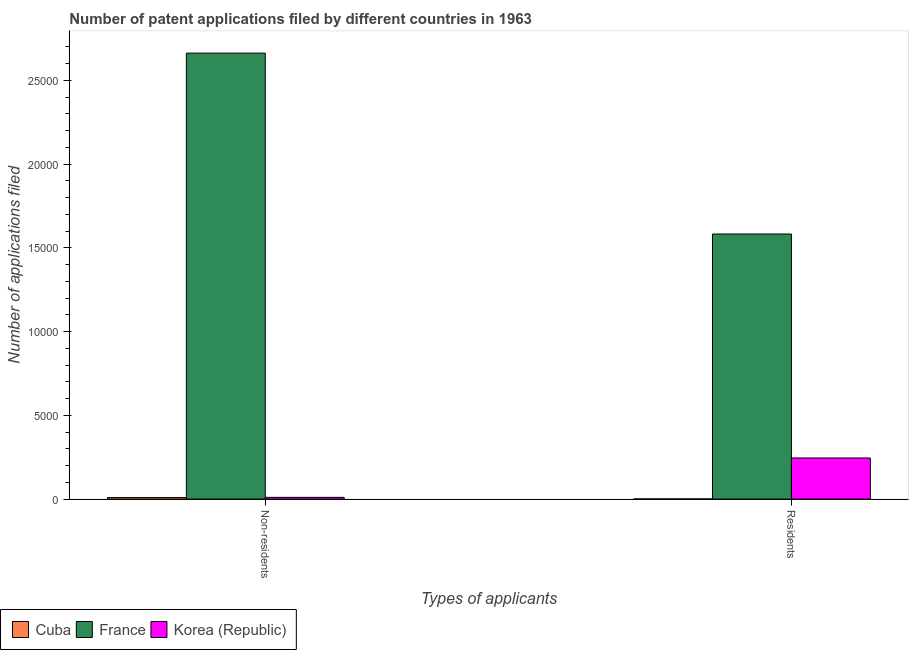Are the number of bars per tick equal to the number of legend labels?
Your answer should be very brief. Yes. How many bars are there on the 1st tick from the right?
Offer a terse response. 3. What is the label of the 2nd group of bars from the left?
Your response must be concise. Residents. What is the number of patent applications by non residents in Cuba?
Offer a terse response. 92. Across all countries, what is the maximum number of patent applications by non residents?
Provide a succinct answer. 2.66e+04. Across all countries, what is the minimum number of patent applications by non residents?
Keep it short and to the point. 92. In which country was the number of patent applications by residents maximum?
Your answer should be very brief. France. In which country was the number of patent applications by residents minimum?
Offer a terse response. Cuba. What is the total number of patent applications by residents in the graph?
Offer a very short reply. 1.83e+04. What is the difference between the number of patent applications by residents in Korea (Republic) and that in Cuba?
Offer a terse response. 2447. What is the difference between the number of patent applications by non residents in France and the number of patent applications by residents in Korea (Republic)?
Offer a very short reply. 2.42e+04. What is the average number of patent applications by non residents per country?
Your answer should be very brief. 8939.67. What is the difference between the number of patent applications by residents and number of patent applications by non residents in Korea (Republic)?
Provide a succinct answer. 2352. In how many countries, is the number of patent applications by non residents greater than 21000 ?
Your answer should be very brief. 1. What is the ratio of the number of patent applications by non residents in Cuba to that in Korea (Republic)?
Offer a very short reply. 0.89. Is the number of patent applications by non residents in France less than that in Cuba?
Offer a very short reply. No. What does the 1st bar from the left in Non-residents represents?
Offer a very short reply. Cuba. How many countries are there in the graph?
Make the answer very short. 3. Does the graph contain any zero values?
Offer a terse response. No. Where does the legend appear in the graph?
Make the answer very short. Bottom left. How many legend labels are there?
Provide a short and direct response. 3. How are the legend labels stacked?
Your response must be concise. Horizontal. What is the title of the graph?
Keep it short and to the point. Number of patent applications filed by different countries in 1963. What is the label or title of the X-axis?
Your answer should be compact. Types of applicants. What is the label or title of the Y-axis?
Offer a terse response. Number of applications filed. What is the Number of applications filed of Cuba in Non-residents?
Your response must be concise. 92. What is the Number of applications filed in France in Non-residents?
Provide a succinct answer. 2.66e+04. What is the Number of applications filed in Korea (Republic) in Non-residents?
Provide a succinct answer. 103. What is the Number of applications filed of France in Residents?
Your answer should be compact. 1.58e+04. What is the Number of applications filed in Korea (Republic) in Residents?
Your response must be concise. 2455. Across all Types of applicants, what is the maximum Number of applications filed in Cuba?
Provide a succinct answer. 92. Across all Types of applicants, what is the maximum Number of applications filed in France?
Your response must be concise. 2.66e+04. Across all Types of applicants, what is the maximum Number of applications filed of Korea (Republic)?
Provide a short and direct response. 2455. Across all Types of applicants, what is the minimum Number of applications filed in France?
Provide a short and direct response. 1.58e+04. Across all Types of applicants, what is the minimum Number of applications filed in Korea (Republic)?
Make the answer very short. 103. What is the total Number of applications filed in France in the graph?
Ensure brevity in your answer.  4.24e+04. What is the total Number of applications filed of Korea (Republic) in the graph?
Your answer should be very brief. 2558. What is the difference between the Number of applications filed in Cuba in Non-residents and that in Residents?
Your answer should be very brief. 84. What is the difference between the Number of applications filed of France in Non-residents and that in Residents?
Make the answer very short. 1.08e+04. What is the difference between the Number of applications filed in Korea (Republic) in Non-residents and that in Residents?
Provide a short and direct response. -2352. What is the difference between the Number of applications filed of Cuba in Non-residents and the Number of applications filed of France in Residents?
Your response must be concise. -1.57e+04. What is the difference between the Number of applications filed in Cuba in Non-residents and the Number of applications filed in Korea (Republic) in Residents?
Your answer should be very brief. -2363. What is the difference between the Number of applications filed in France in Non-residents and the Number of applications filed in Korea (Republic) in Residents?
Provide a succinct answer. 2.42e+04. What is the average Number of applications filed in France per Types of applicants?
Offer a very short reply. 2.12e+04. What is the average Number of applications filed in Korea (Republic) per Types of applicants?
Your answer should be very brief. 1279. What is the difference between the Number of applications filed of Cuba and Number of applications filed of France in Non-residents?
Your answer should be compact. -2.65e+04. What is the difference between the Number of applications filed in Cuba and Number of applications filed in Korea (Republic) in Non-residents?
Make the answer very short. -11. What is the difference between the Number of applications filed of France and Number of applications filed of Korea (Republic) in Non-residents?
Give a very brief answer. 2.65e+04. What is the difference between the Number of applications filed in Cuba and Number of applications filed in France in Residents?
Provide a succinct answer. -1.58e+04. What is the difference between the Number of applications filed in Cuba and Number of applications filed in Korea (Republic) in Residents?
Make the answer very short. -2447. What is the difference between the Number of applications filed in France and Number of applications filed in Korea (Republic) in Residents?
Offer a terse response. 1.34e+04. What is the ratio of the Number of applications filed in Cuba in Non-residents to that in Residents?
Your answer should be compact. 11.5. What is the ratio of the Number of applications filed of France in Non-residents to that in Residents?
Your response must be concise. 1.68. What is the ratio of the Number of applications filed of Korea (Republic) in Non-residents to that in Residents?
Provide a succinct answer. 0.04. What is the difference between the highest and the second highest Number of applications filed in Cuba?
Offer a terse response. 84. What is the difference between the highest and the second highest Number of applications filed of France?
Give a very brief answer. 1.08e+04. What is the difference between the highest and the second highest Number of applications filed in Korea (Republic)?
Provide a short and direct response. 2352. What is the difference between the highest and the lowest Number of applications filed of France?
Give a very brief answer. 1.08e+04. What is the difference between the highest and the lowest Number of applications filed of Korea (Republic)?
Provide a short and direct response. 2352. 